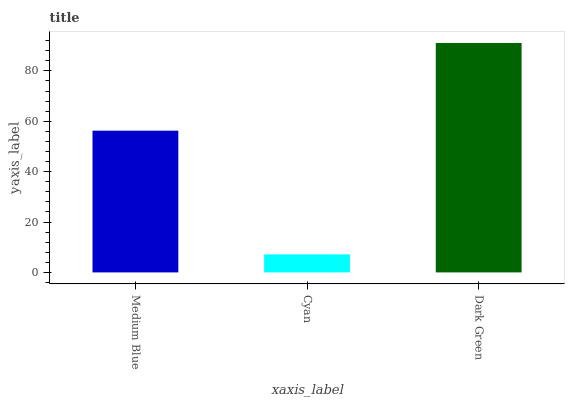Is Cyan the minimum?
Answer yes or no. Yes. Is Dark Green the maximum?
Answer yes or no. Yes. Is Dark Green the minimum?
Answer yes or no. No. Is Cyan the maximum?
Answer yes or no. No. Is Dark Green greater than Cyan?
Answer yes or no. Yes. Is Cyan less than Dark Green?
Answer yes or no. Yes. Is Cyan greater than Dark Green?
Answer yes or no. No. Is Dark Green less than Cyan?
Answer yes or no. No. Is Medium Blue the high median?
Answer yes or no. Yes. Is Medium Blue the low median?
Answer yes or no. Yes. Is Cyan the high median?
Answer yes or no. No. Is Dark Green the low median?
Answer yes or no. No. 